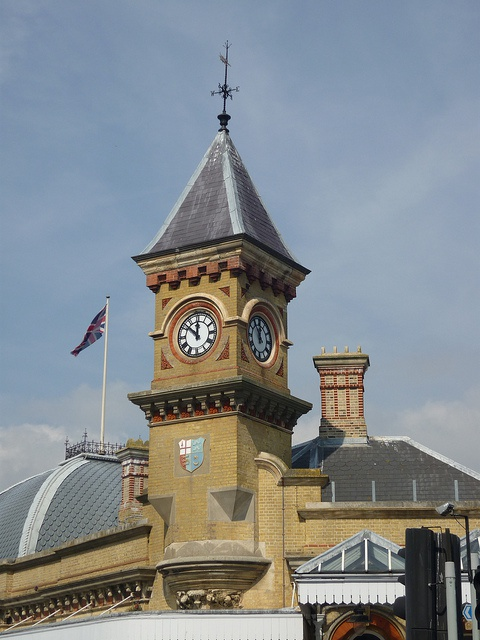Describe the objects in this image and their specific colors. I can see clock in gray, lightgray, black, and darkgray tones and clock in gray and black tones in this image. 